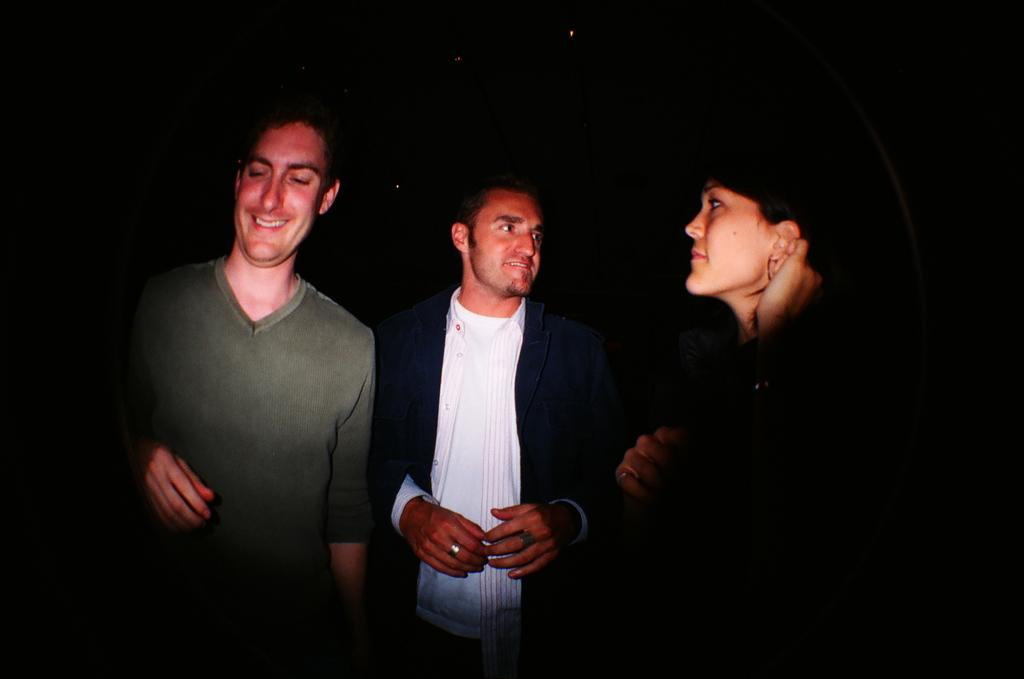How many people are in the image? There are three persons standing in the center of the image. What can be observed about the background of the image? The background of the image is dark. How many cattle are present in the image? There are no cattle visible in the image. What part of the image is described as a hole? There is no mention of a hole in the image; the background is described as dark. 